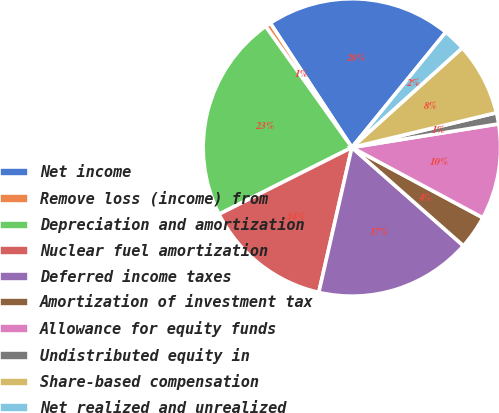Convert chart. <chart><loc_0><loc_0><loc_500><loc_500><pie_chart><fcel>Net income<fcel>Remove loss (income) from<fcel>Depreciation and amortization<fcel>Nuclear fuel amortization<fcel>Deferred income taxes<fcel>Amortization of investment tax<fcel>Allowance for equity funds<fcel>Undistributed equity in<fcel>Share-based compensation<fcel>Net realized and unrealized<nl><fcel>20.12%<fcel>0.61%<fcel>22.56%<fcel>14.02%<fcel>17.07%<fcel>3.66%<fcel>10.37%<fcel>1.22%<fcel>7.93%<fcel>2.44%<nl></chart> 